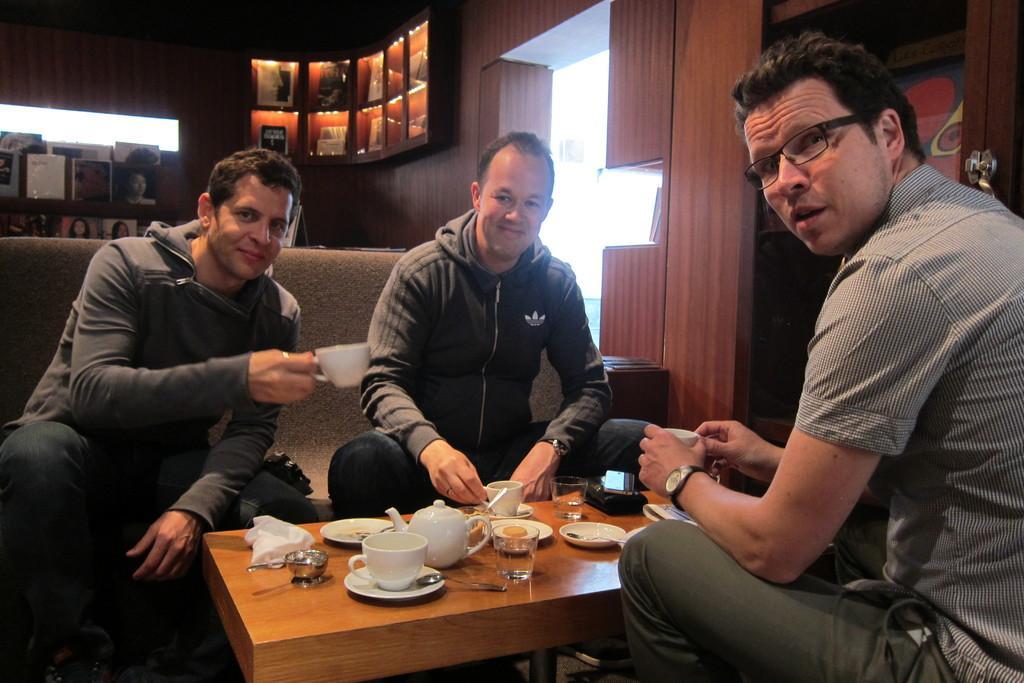Could you give a brief overview of what you see in this image? This image is taken indoors. In the background there is a wall and there is a door. There are a few picture frames on the wall. There are a few shelves. There are a few objects on the shelves. In the middle of the image two men are sitting on the couch and they are with smiling faces and a man is holding a cup in his hand. On the right side of the image a man is sitting on the chair and he is holding a cup in his hands. At the bottom of the image there is a table with a kettle, a glass, a few plates, a wallet and many things on it. 